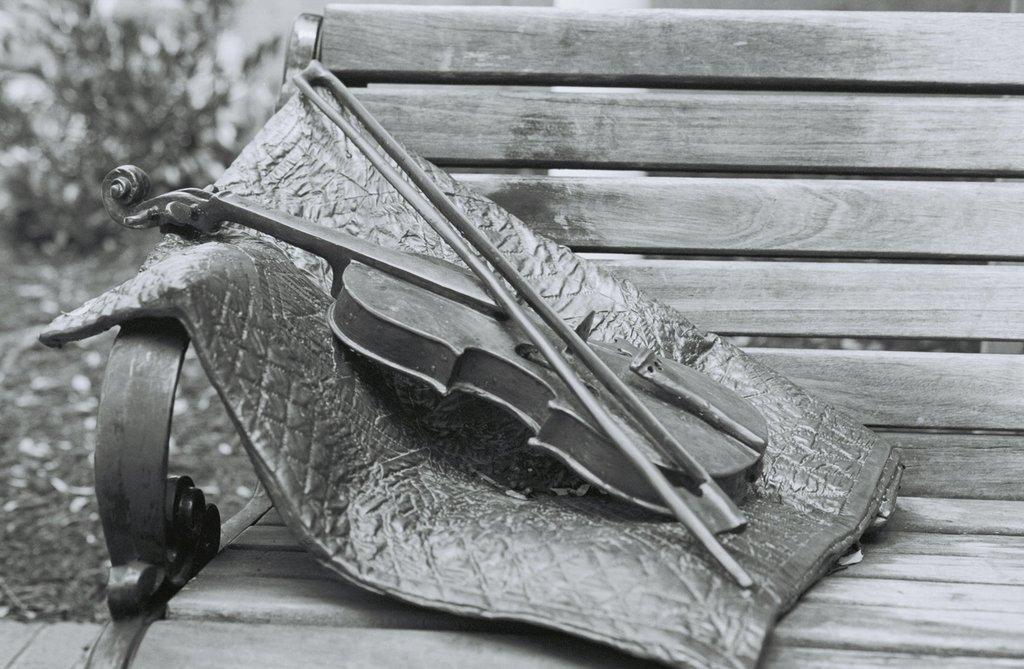How would you summarize this image in a sentence or two? It looks like a black and white picture. We can see there is a violin with a bow and an object on the bench. Behind the bench there are trees. 